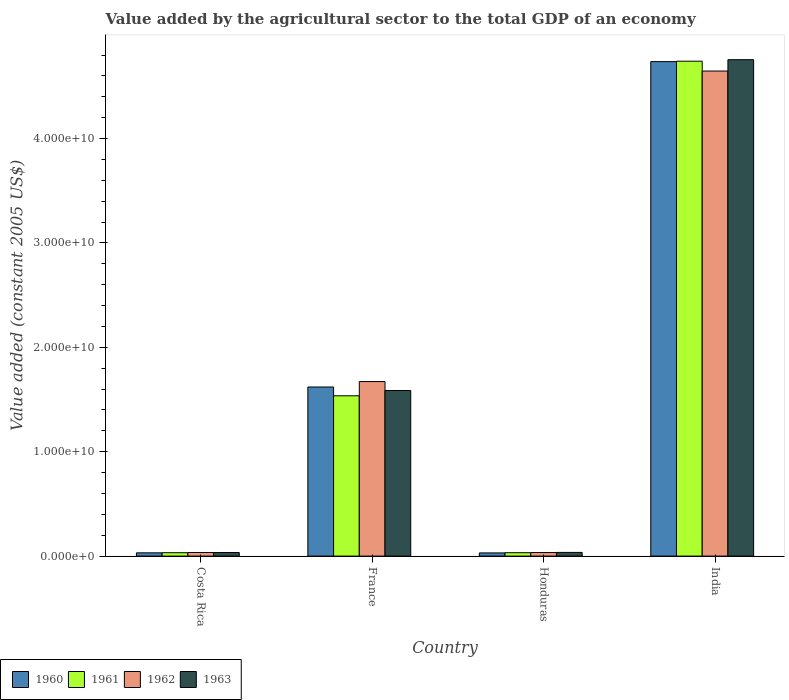How many bars are there on the 3rd tick from the right?
Your answer should be very brief. 4. What is the value added by the agricultural sector in 1960 in India?
Provide a short and direct response. 4.74e+1. Across all countries, what is the maximum value added by the agricultural sector in 1962?
Make the answer very short. 4.65e+1. Across all countries, what is the minimum value added by the agricultural sector in 1962?
Your response must be concise. 3.41e+08. In which country was the value added by the agricultural sector in 1960 maximum?
Ensure brevity in your answer.  India. In which country was the value added by the agricultural sector in 1961 minimum?
Your answer should be compact. Costa Rica. What is the total value added by the agricultural sector in 1963 in the graph?
Make the answer very short. 6.41e+1. What is the difference between the value added by the agricultural sector in 1961 in Costa Rica and that in France?
Provide a short and direct response. -1.50e+1. What is the difference between the value added by the agricultural sector in 1963 in Costa Rica and the value added by the agricultural sector in 1961 in France?
Make the answer very short. -1.50e+1. What is the average value added by the agricultural sector in 1960 per country?
Offer a terse response. 1.60e+1. What is the difference between the value added by the agricultural sector of/in 1960 and value added by the agricultural sector of/in 1963 in Honduras?
Provide a short and direct response. -4.78e+07. In how many countries, is the value added by the agricultural sector in 1963 greater than 18000000000 US$?
Ensure brevity in your answer.  1. What is the ratio of the value added by the agricultural sector in 1962 in France to that in Honduras?
Your response must be concise. 49.07. Is the value added by the agricultural sector in 1961 in France less than that in India?
Provide a short and direct response. Yes. Is the difference between the value added by the agricultural sector in 1960 in Costa Rica and Honduras greater than the difference between the value added by the agricultural sector in 1963 in Costa Rica and Honduras?
Your answer should be very brief. Yes. What is the difference between the highest and the second highest value added by the agricultural sector in 1962?
Keep it short and to the point. 4.61e+1. What is the difference between the highest and the lowest value added by the agricultural sector in 1960?
Your response must be concise. 4.71e+1. In how many countries, is the value added by the agricultural sector in 1962 greater than the average value added by the agricultural sector in 1962 taken over all countries?
Your answer should be very brief. 2. Is the sum of the value added by the agricultural sector in 1961 in France and India greater than the maximum value added by the agricultural sector in 1960 across all countries?
Ensure brevity in your answer.  Yes. Are all the bars in the graph horizontal?
Ensure brevity in your answer.  No. What is the difference between two consecutive major ticks on the Y-axis?
Provide a short and direct response. 1.00e+1. Are the values on the major ticks of Y-axis written in scientific E-notation?
Your answer should be very brief. Yes. How many legend labels are there?
Your response must be concise. 4. What is the title of the graph?
Your answer should be compact. Value added by the agricultural sector to the total GDP of an economy. Does "1996" appear as one of the legend labels in the graph?
Provide a succinct answer. No. What is the label or title of the Y-axis?
Make the answer very short. Value added (constant 2005 US$). What is the Value added (constant 2005 US$) in 1960 in Costa Rica?
Your answer should be compact. 3.13e+08. What is the Value added (constant 2005 US$) of 1961 in Costa Rica?
Offer a terse response. 3.24e+08. What is the Value added (constant 2005 US$) in 1962 in Costa Rica?
Give a very brief answer. 3.44e+08. What is the Value added (constant 2005 US$) in 1963 in Costa Rica?
Keep it short and to the point. 3.43e+08. What is the Value added (constant 2005 US$) in 1960 in France?
Keep it short and to the point. 1.62e+1. What is the Value added (constant 2005 US$) of 1961 in France?
Ensure brevity in your answer.  1.54e+1. What is the Value added (constant 2005 US$) of 1962 in France?
Keep it short and to the point. 1.67e+1. What is the Value added (constant 2005 US$) of 1963 in France?
Offer a terse response. 1.59e+1. What is the Value added (constant 2005 US$) of 1960 in Honduras?
Your answer should be compact. 3.05e+08. What is the Value added (constant 2005 US$) of 1961 in Honduras?
Ensure brevity in your answer.  3.25e+08. What is the Value added (constant 2005 US$) in 1962 in Honduras?
Give a very brief answer. 3.41e+08. What is the Value added (constant 2005 US$) in 1963 in Honduras?
Make the answer very short. 3.53e+08. What is the Value added (constant 2005 US$) in 1960 in India?
Provide a succinct answer. 4.74e+1. What is the Value added (constant 2005 US$) of 1961 in India?
Provide a short and direct response. 4.74e+1. What is the Value added (constant 2005 US$) of 1962 in India?
Your answer should be compact. 4.65e+1. What is the Value added (constant 2005 US$) of 1963 in India?
Ensure brevity in your answer.  4.76e+1. Across all countries, what is the maximum Value added (constant 2005 US$) in 1960?
Your answer should be compact. 4.74e+1. Across all countries, what is the maximum Value added (constant 2005 US$) of 1961?
Offer a terse response. 4.74e+1. Across all countries, what is the maximum Value added (constant 2005 US$) of 1962?
Give a very brief answer. 4.65e+1. Across all countries, what is the maximum Value added (constant 2005 US$) in 1963?
Your answer should be compact. 4.76e+1. Across all countries, what is the minimum Value added (constant 2005 US$) in 1960?
Ensure brevity in your answer.  3.05e+08. Across all countries, what is the minimum Value added (constant 2005 US$) of 1961?
Your answer should be very brief. 3.24e+08. Across all countries, what is the minimum Value added (constant 2005 US$) of 1962?
Provide a succinct answer. 3.41e+08. Across all countries, what is the minimum Value added (constant 2005 US$) of 1963?
Offer a very short reply. 3.43e+08. What is the total Value added (constant 2005 US$) in 1960 in the graph?
Your answer should be compact. 6.42e+1. What is the total Value added (constant 2005 US$) in 1961 in the graph?
Your response must be concise. 6.34e+1. What is the total Value added (constant 2005 US$) of 1962 in the graph?
Provide a short and direct response. 6.39e+1. What is the total Value added (constant 2005 US$) in 1963 in the graph?
Your answer should be compact. 6.41e+1. What is the difference between the Value added (constant 2005 US$) of 1960 in Costa Rica and that in France?
Your response must be concise. -1.59e+1. What is the difference between the Value added (constant 2005 US$) in 1961 in Costa Rica and that in France?
Keep it short and to the point. -1.50e+1. What is the difference between the Value added (constant 2005 US$) of 1962 in Costa Rica and that in France?
Offer a very short reply. -1.64e+1. What is the difference between the Value added (constant 2005 US$) in 1963 in Costa Rica and that in France?
Your answer should be compact. -1.55e+1. What is the difference between the Value added (constant 2005 US$) in 1960 in Costa Rica and that in Honduras?
Offer a terse response. 7.61e+06. What is the difference between the Value added (constant 2005 US$) in 1961 in Costa Rica and that in Honduras?
Offer a very short reply. -8.14e+05. What is the difference between the Value added (constant 2005 US$) of 1962 in Costa Rica and that in Honduras?
Ensure brevity in your answer.  3.61e+06. What is the difference between the Value added (constant 2005 US$) in 1963 in Costa Rica and that in Honduras?
Your response must be concise. -9.78e+06. What is the difference between the Value added (constant 2005 US$) in 1960 in Costa Rica and that in India?
Ensure brevity in your answer.  -4.71e+1. What is the difference between the Value added (constant 2005 US$) in 1961 in Costa Rica and that in India?
Provide a succinct answer. -4.71e+1. What is the difference between the Value added (constant 2005 US$) in 1962 in Costa Rica and that in India?
Make the answer very short. -4.61e+1. What is the difference between the Value added (constant 2005 US$) in 1963 in Costa Rica and that in India?
Provide a short and direct response. -4.72e+1. What is the difference between the Value added (constant 2005 US$) in 1960 in France and that in Honduras?
Provide a succinct answer. 1.59e+1. What is the difference between the Value added (constant 2005 US$) in 1961 in France and that in Honduras?
Give a very brief answer. 1.50e+1. What is the difference between the Value added (constant 2005 US$) in 1962 in France and that in Honduras?
Your answer should be compact. 1.64e+1. What is the difference between the Value added (constant 2005 US$) in 1963 in France and that in Honduras?
Your answer should be very brief. 1.55e+1. What is the difference between the Value added (constant 2005 US$) of 1960 in France and that in India?
Offer a terse response. -3.12e+1. What is the difference between the Value added (constant 2005 US$) in 1961 in France and that in India?
Ensure brevity in your answer.  -3.21e+1. What is the difference between the Value added (constant 2005 US$) in 1962 in France and that in India?
Ensure brevity in your answer.  -2.97e+1. What is the difference between the Value added (constant 2005 US$) in 1963 in France and that in India?
Your response must be concise. -3.17e+1. What is the difference between the Value added (constant 2005 US$) of 1960 in Honduras and that in India?
Provide a succinct answer. -4.71e+1. What is the difference between the Value added (constant 2005 US$) in 1961 in Honduras and that in India?
Offer a terse response. -4.71e+1. What is the difference between the Value added (constant 2005 US$) of 1962 in Honduras and that in India?
Provide a short and direct response. -4.61e+1. What is the difference between the Value added (constant 2005 US$) of 1963 in Honduras and that in India?
Provide a short and direct response. -4.72e+1. What is the difference between the Value added (constant 2005 US$) in 1960 in Costa Rica and the Value added (constant 2005 US$) in 1961 in France?
Give a very brief answer. -1.50e+1. What is the difference between the Value added (constant 2005 US$) in 1960 in Costa Rica and the Value added (constant 2005 US$) in 1962 in France?
Your answer should be compact. -1.64e+1. What is the difference between the Value added (constant 2005 US$) in 1960 in Costa Rica and the Value added (constant 2005 US$) in 1963 in France?
Your response must be concise. -1.56e+1. What is the difference between the Value added (constant 2005 US$) in 1961 in Costa Rica and the Value added (constant 2005 US$) in 1962 in France?
Offer a very short reply. -1.64e+1. What is the difference between the Value added (constant 2005 US$) of 1961 in Costa Rica and the Value added (constant 2005 US$) of 1963 in France?
Ensure brevity in your answer.  -1.55e+1. What is the difference between the Value added (constant 2005 US$) of 1962 in Costa Rica and the Value added (constant 2005 US$) of 1963 in France?
Your response must be concise. -1.55e+1. What is the difference between the Value added (constant 2005 US$) in 1960 in Costa Rica and the Value added (constant 2005 US$) in 1961 in Honduras?
Your answer should be very brief. -1.23e+07. What is the difference between the Value added (constant 2005 US$) of 1960 in Costa Rica and the Value added (constant 2005 US$) of 1962 in Honduras?
Offer a very short reply. -2.78e+07. What is the difference between the Value added (constant 2005 US$) of 1960 in Costa Rica and the Value added (constant 2005 US$) of 1963 in Honduras?
Give a very brief answer. -4.02e+07. What is the difference between the Value added (constant 2005 US$) in 1961 in Costa Rica and the Value added (constant 2005 US$) in 1962 in Honduras?
Offer a terse response. -1.63e+07. What is the difference between the Value added (constant 2005 US$) of 1961 in Costa Rica and the Value added (constant 2005 US$) of 1963 in Honduras?
Provide a short and direct response. -2.87e+07. What is the difference between the Value added (constant 2005 US$) in 1962 in Costa Rica and the Value added (constant 2005 US$) in 1963 in Honduras?
Ensure brevity in your answer.  -8.78e+06. What is the difference between the Value added (constant 2005 US$) of 1960 in Costa Rica and the Value added (constant 2005 US$) of 1961 in India?
Offer a terse response. -4.71e+1. What is the difference between the Value added (constant 2005 US$) of 1960 in Costa Rica and the Value added (constant 2005 US$) of 1962 in India?
Make the answer very short. -4.62e+1. What is the difference between the Value added (constant 2005 US$) of 1960 in Costa Rica and the Value added (constant 2005 US$) of 1963 in India?
Offer a very short reply. -4.72e+1. What is the difference between the Value added (constant 2005 US$) of 1961 in Costa Rica and the Value added (constant 2005 US$) of 1962 in India?
Give a very brief answer. -4.61e+1. What is the difference between the Value added (constant 2005 US$) in 1961 in Costa Rica and the Value added (constant 2005 US$) in 1963 in India?
Offer a very short reply. -4.72e+1. What is the difference between the Value added (constant 2005 US$) of 1962 in Costa Rica and the Value added (constant 2005 US$) of 1963 in India?
Provide a short and direct response. -4.72e+1. What is the difference between the Value added (constant 2005 US$) of 1960 in France and the Value added (constant 2005 US$) of 1961 in Honduras?
Ensure brevity in your answer.  1.59e+1. What is the difference between the Value added (constant 2005 US$) of 1960 in France and the Value added (constant 2005 US$) of 1962 in Honduras?
Your answer should be compact. 1.59e+1. What is the difference between the Value added (constant 2005 US$) in 1960 in France and the Value added (constant 2005 US$) in 1963 in Honduras?
Offer a terse response. 1.58e+1. What is the difference between the Value added (constant 2005 US$) in 1961 in France and the Value added (constant 2005 US$) in 1962 in Honduras?
Keep it short and to the point. 1.50e+1. What is the difference between the Value added (constant 2005 US$) in 1961 in France and the Value added (constant 2005 US$) in 1963 in Honduras?
Offer a terse response. 1.50e+1. What is the difference between the Value added (constant 2005 US$) of 1962 in France and the Value added (constant 2005 US$) of 1963 in Honduras?
Give a very brief answer. 1.64e+1. What is the difference between the Value added (constant 2005 US$) of 1960 in France and the Value added (constant 2005 US$) of 1961 in India?
Ensure brevity in your answer.  -3.12e+1. What is the difference between the Value added (constant 2005 US$) of 1960 in France and the Value added (constant 2005 US$) of 1962 in India?
Provide a short and direct response. -3.03e+1. What is the difference between the Value added (constant 2005 US$) in 1960 in France and the Value added (constant 2005 US$) in 1963 in India?
Make the answer very short. -3.14e+1. What is the difference between the Value added (constant 2005 US$) in 1961 in France and the Value added (constant 2005 US$) in 1962 in India?
Keep it short and to the point. -3.11e+1. What is the difference between the Value added (constant 2005 US$) in 1961 in France and the Value added (constant 2005 US$) in 1963 in India?
Provide a succinct answer. -3.22e+1. What is the difference between the Value added (constant 2005 US$) in 1962 in France and the Value added (constant 2005 US$) in 1963 in India?
Keep it short and to the point. -3.08e+1. What is the difference between the Value added (constant 2005 US$) in 1960 in Honduras and the Value added (constant 2005 US$) in 1961 in India?
Your answer should be compact. -4.71e+1. What is the difference between the Value added (constant 2005 US$) of 1960 in Honduras and the Value added (constant 2005 US$) of 1962 in India?
Your response must be concise. -4.62e+1. What is the difference between the Value added (constant 2005 US$) of 1960 in Honduras and the Value added (constant 2005 US$) of 1963 in India?
Provide a short and direct response. -4.72e+1. What is the difference between the Value added (constant 2005 US$) of 1961 in Honduras and the Value added (constant 2005 US$) of 1962 in India?
Your response must be concise. -4.61e+1. What is the difference between the Value added (constant 2005 US$) of 1961 in Honduras and the Value added (constant 2005 US$) of 1963 in India?
Make the answer very short. -4.72e+1. What is the difference between the Value added (constant 2005 US$) of 1962 in Honduras and the Value added (constant 2005 US$) of 1963 in India?
Ensure brevity in your answer.  -4.72e+1. What is the average Value added (constant 2005 US$) of 1960 per country?
Your answer should be very brief. 1.60e+1. What is the average Value added (constant 2005 US$) in 1961 per country?
Your answer should be compact. 1.59e+1. What is the average Value added (constant 2005 US$) in 1962 per country?
Offer a terse response. 1.60e+1. What is the average Value added (constant 2005 US$) of 1963 per country?
Offer a terse response. 1.60e+1. What is the difference between the Value added (constant 2005 US$) of 1960 and Value added (constant 2005 US$) of 1961 in Costa Rica?
Your response must be concise. -1.15e+07. What is the difference between the Value added (constant 2005 US$) of 1960 and Value added (constant 2005 US$) of 1962 in Costa Rica?
Your answer should be compact. -3.14e+07. What is the difference between the Value added (constant 2005 US$) of 1960 and Value added (constant 2005 US$) of 1963 in Costa Rica?
Make the answer very short. -3.04e+07. What is the difference between the Value added (constant 2005 US$) of 1961 and Value added (constant 2005 US$) of 1962 in Costa Rica?
Make the answer very short. -1.99e+07. What is the difference between the Value added (constant 2005 US$) of 1961 and Value added (constant 2005 US$) of 1963 in Costa Rica?
Your answer should be compact. -1.89e+07. What is the difference between the Value added (constant 2005 US$) of 1962 and Value added (constant 2005 US$) of 1963 in Costa Rica?
Give a very brief answer. 1.00e+06. What is the difference between the Value added (constant 2005 US$) of 1960 and Value added (constant 2005 US$) of 1961 in France?
Your answer should be very brief. 8.42e+08. What is the difference between the Value added (constant 2005 US$) in 1960 and Value added (constant 2005 US$) in 1962 in France?
Offer a very short reply. -5.20e+08. What is the difference between the Value added (constant 2005 US$) in 1960 and Value added (constant 2005 US$) in 1963 in France?
Your answer should be very brief. 3.35e+08. What is the difference between the Value added (constant 2005 US$) of 1961 and Value added (constant 2005 US$) of 1962 in France?
Provide a succinct answer. -1.36e+09. What is the difference between the Value added (constant 2005 US$) in 1961 and Value added (constant 2005 US$) in 1963 in France?
Offer a very short reply. -5.07e+08. What is the difference between the Value added (constant 2005 US$) of 1962 and Value added (constant 2005 US$) of 1963 in France?
Your answer should be compact. 8.56e+08. What is the difference between the Value added (constant 2005 US$) in 1960 and Value added (constant 2005 US$) in 1961 in Honduras?
Make the answer very short. -1.99e+07. What is the difference between the Value added (constant 2005 US$) in 1960 and Value added (constant 2005 US$) in 1962 in Honduras?
Provide a short and direct response. -3.54e+07. What is the difference between the Value added (constant 2005 US$) of 1960 and Value added (constant 2005 US$) of 1963 in Honduras?
Give a very brief answer. -4.78e+07. What is the difference between the Value added (constant 2005 US$) of 1961 and Value added (constant 2005 US$) of 1962 in Honduras?
Provide a short and direct response. -1.55e+07. What is the difference between the Value added (constant 2005 US$) in 1961 and Value added (constant 2005 US$) in 1963 in Honduras?
Keep it short and to the point. -2.79e+07. What is the difference between the Value added (constant 2005 US$) of 1962 and Value added (constant 2005 US$) of 1963 in Honduras?
Your answer should be compact. -1.24e+07. What is the difference between the Value added (constant 2005 US$) in 1960 and Value added (constant 2005 US$) in 1961 in India?
Offer a very short reply. -3.99e+07. What is the difference between the Value added (constant 2005 US$) of 1960 and Value added (constant 2005 US$) of 1962 in India?
Provide a short and direct response. 9.03e+08. What is the difference between the Value added (constant 2005 US$) in 1960 and Value added (constant 2005 US$) in 1963 in India?
Provide a succinct answer. -1.84e+08. What is the difference between the Value added (constant 2005 US$) in 1961 and Value added (constant 2005 US$) in 1962 in India?
Offer a terse response. 9.43e+08. What is the difference between the Value added (constant 2005 US$) in 1961 and Value added (constant 2005 US$) in 1963 in India?
Keep it short and to the point. -1.44e+08. What is the difference between the Value added (constant 2005 US$) in 1962 and Value added (constant 2005 US$) in 1963 in India?
Provide a succinct answer. -1.09e+09. What is the ratio of the Value added (constant 2005 US$) of 1960 in Costa Rica to that in France?
Provide a short and direct response. 0.02. What is the ratio of the Value added (constant 2005 US$) of 1961 in Costa Rica to that in France?
Make the answer very short. 0.02. What is the ratio of the Value added (constant 2005 US$) in 1962 in Costa Rica to that in France?
Offer a terse response. 0.02. What is the ratio of the Value added (constant 2005 US$) of 1963 in Costa Rica to that in France?
Your response must be concise. 0.02. What is the ratio of the Value added (constant 2005 US$) in 1960 in Costa Rica to that in Honduras?
Keep it short and to the point. 1.02. What is the ratio of the Value added (constant 2005 US$) of 1962 in Costa Rica to that in Honduras?
Your answer should be very brief. 1.01. What is the ratio of the Value added (constant 2005 US$) in 1963 in Costa Rica to that in Honduras?
Your answer should be very brief. 0.97. What is the ratio of the Value added (constant 2005 US$) of 1960 in Costa Rica to that in India?
Your answer should be compact. 0.01. What is the ratio of the Value added (constant 2005 US$) of 1961 in Costa Rica to that in India?
Provide a short and direct response. 0.01. What is the ratio of the Value added (constant 2005 US$) of 1962 in Costa Rica to that in India?
Provide a short and direct response. 0.01. What is the ratio of the Value added (constant 2005 US$) of 1963 in Costa Rica to that in India?
Give a very brief answer. 0.01. What is the ratio of the Value added (constant 2005 US$) in 1960 in France to that in Honduras?
Your response must be concise. 53.05. What is the ratio of the Value added (constant 2005 US$) in 1961 in France to that in Honduras?
Provide a succinct answer. 47.21. What is the ratio of the Value added (constant 2005 US$) in 1962 in France to that in Honduras?
Keep it short and to the point. 49.07. What is the ratio of the Value added (constant 2005 US$) of 1963 in France to that in Honduras?
Provide a short and direct response. 44.92. What is the ratio of the Value added (constant 2005 US$) in 1960 in France to that in India?
Your answer should be compact. 0.34. What is the ratio of the Value added (constant 2005 US$) in 1961 in France to that in India?
Keep it short and to the point. 0.32. What is the ratio of the Value added (constant 2005 US$) of 1962 in France to that in India?
Provide a short and direct response. 0.36. What is the ratio of the Value added (constant 2005 US$) of 1963 in France to that in India?
Keep it short and to the point. 0.33. What is the ratio of the Value added (constant 2005 US$) of 1960 in Honduras to that in India?
Your answer should be very brief. 0.01. What is the ratio of the Value added (constant 2005 US$) of 1961 in Honduras to that in India?
Your response must be concise. 0.01. What is the ratio of the Value added (constant 2005 US$) of 1962 in Honduras to that in India?
Ensure brevity in your answer.  0.01. What is the ratio of the Value added (constant 2005 US$) in 1963 in Honduras to that in India?
Offer a terse response. 0.01. What is the difference between the highest and the second highest Value added (constant 2005 US$) of 1960?
Ensure brevity in your answer.  3.12e+1. What is the difference between the highest and the second highest Value added (constant 2005 US$) in 1961?
Provide a succinct answer. 3.21e+1. What is the difference between the highest and the second highest Value added (constant 2005 US$) in 1962?
Offer a very short reply. 2.97e+1. What is the difference between the highest and the second highest Value added (constant 2005 US$) of 1963?
Your response must be concise. 3.17e+1. What is the difference between the highest and the lowest Value added (constant 2005 US$) of 1960?
Your answer should be compact. 4.71e+1. What is the difference between the highest and the lowest Value added (constant 2005 US$) in 1961?
Make the answer very short. 4.71e+1. What is the difference between the highest and the lowest Value added (constant 2005 US$) in 1962?
Provide a short and direct response. 4.61e+1. What is the difference between the highest and the lowest Value added (constant 2005 US$) in 1963?
Make the answer very short. 4.72e+1. 